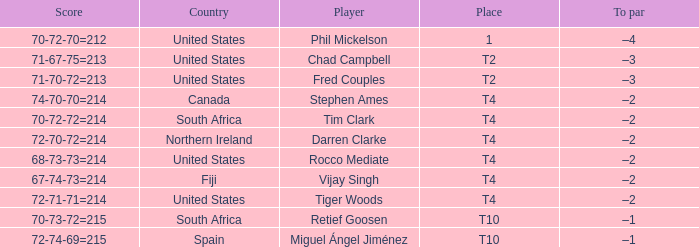What country is Chad Campbell from? United States. 